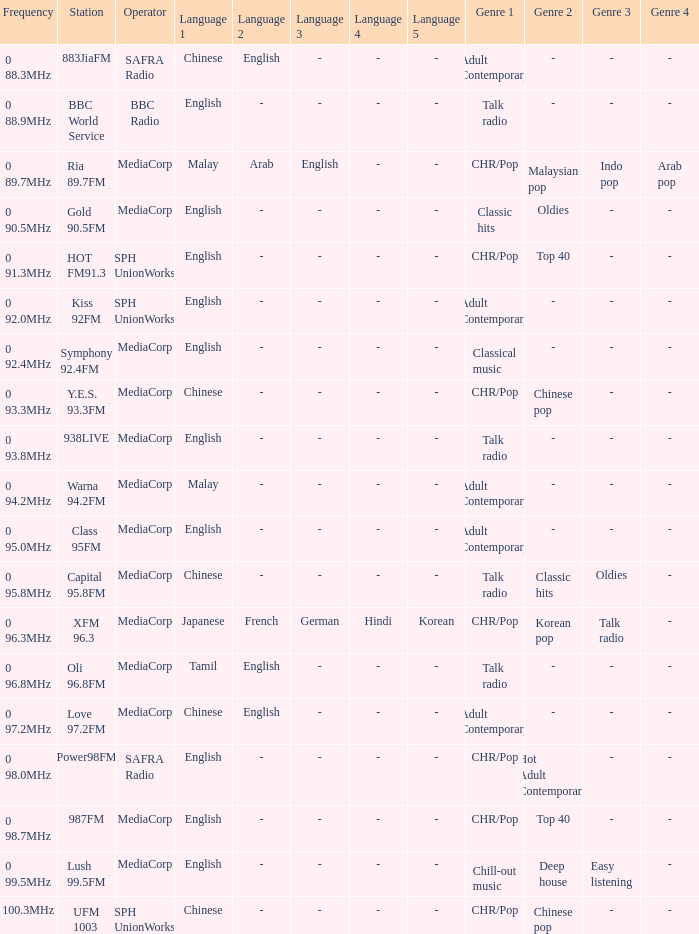What is the genre of the BBC World Service? Talk radio. 